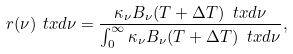Convert formula to latex. <formula><loc_0><loc_0><loc_500><loc_500>r ( \nu ) \ t x d \nu = \frac { \kappa _ { \nu } B _ { \nu } ( T + \Delta T ) \, \ t x d \nu } { \int _ { 0 } ^ { \infty } \kappa _ { \nu } B _ { \nu } ( T + \Delta T ) \, \ t x d \nu } ,</formula> 